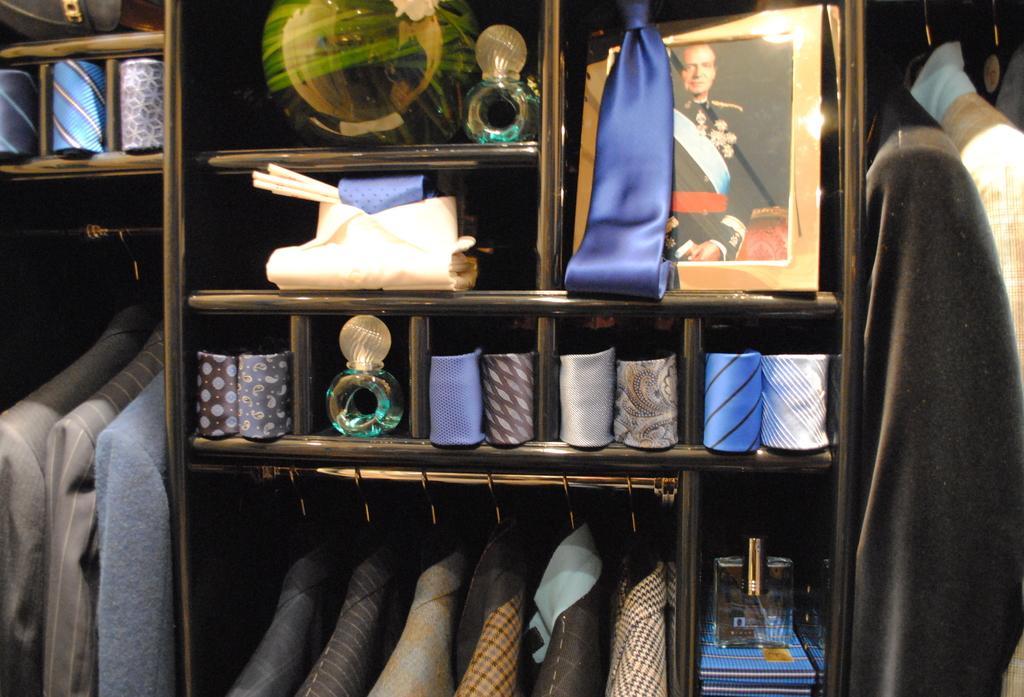Can you describe this image briefly? In this picture there is a rack in the center of the image, which contains clothes in it. 